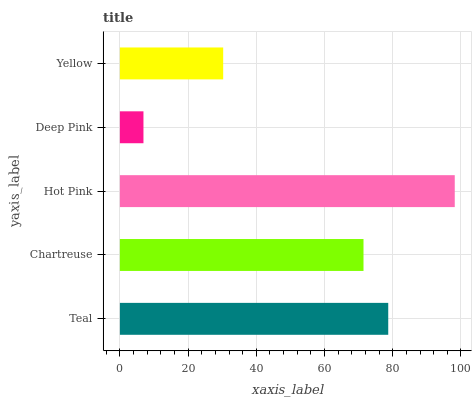Is Deep Pink the minimum?
Answer yes or no. Yes. Is Hot Pink the maximum?
Answer yes or no. Yes. Is Chartreuse the minimum?
Answer yes or no. No. Is Chartreuse the maximum?
Answer yes or no. No. Is Teal greater than Chartreuse?
Answer yes or no. Yes. Is Chartreuse less than Teal?
Answer yes or no. Yes. Is Chartreuse greater than Teal?
Answer yes or no. No. Is Teal less than Chartreuse?
Answer yes or no. No. Is Chartreuse the high median?
Answer yes or no. Yes. Is Chartreuse the low median?
Answer yes or no. Yes. Is Teal the high median?
Answer yes or no. No. Is Hot Pink the low median?
Answer yes or no. No. 